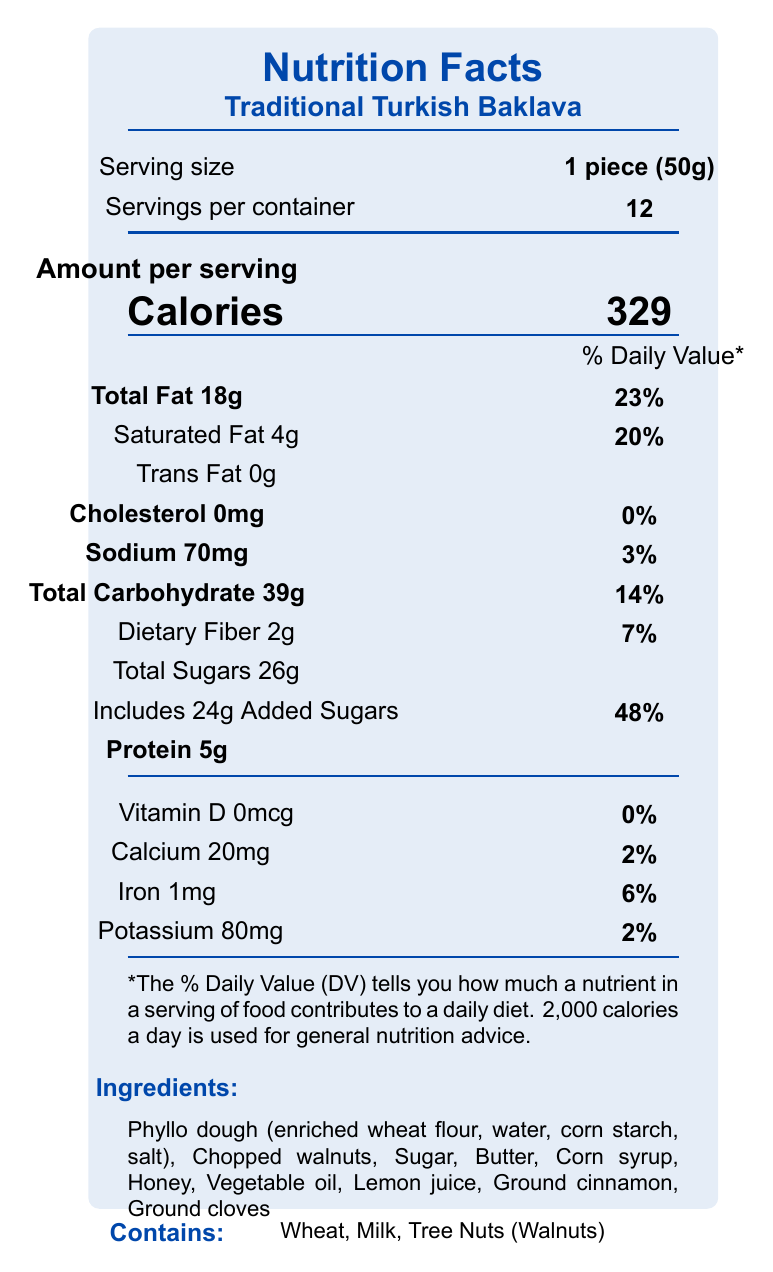What is the calorie content per serving? The document states that there are 329 calories per serving of the Traditional Turkish Baklava.
Answer: 329 calories What is the serving size of the Traditional Turkish Baklava? The serving size is listed as 1 piece, which is approximately 50 grams.
Answer: 1 piece (50g) How many servings are there per container? The document indicates that there are 12 servings per container.
Answer: 12 How much total sugar is in one serving? The document specifies that each serving contains 26 grams of total sugars.
Answer: 26g What are the daily values for saturated fat and sodium? Saturated fat has a daily value of 20% and sodium has a daily value of 3%.
Answer: Saturated Fat: 20%, Sodium: 3% What ingredients are listed as allergens? The document lists wheat, milk, and tree nuts (walnuts) as allergens.
Answer: Wheat, Milk, Tree Nuts (Walnuts) What is the amount of dietary fiber per serving? The document shows that there are 2 grams of dietary fiber per serving.
Answer: 2g Which nutrient contributes 48% of the daily value per serving? The document indicates that added sugars contribute 48% to the daily value.
Answer: Added Sugars How much protein is in one piece of baklava? According to the document, there are 5 grams of protein in each serving.
Answer: 5g How should the baklava be stored according to the storage instructions? The document suggests storing the baklava in an airtight container at room temperature for up to 5 days.
Answer: Store in an airtight container at room temperature for up to 5 days What is the daily value percentage for calcium? The document lists the daily value percentage for calcium as 2%.
Answer: 2% What are the main ingredients in the Traditional Turkish Baklava? A. Phyllo dough, walnuts, sugar B. Butter, corn syrup, honey C. Vegetable oil, lemon juice, cinnamon D. All of the above The main ingredients include phyllo dough, walnuts, sugar, butter, corn syrup, honey, vegetable oil, lemon juice, and cinnamon, which are all included in the options.
Answer: D. All of the above Which of the following nutrients is not present in the baklava? I. Vitamin D II. Cholesterol III. Trans Fat A. I only B. I and II only C. II and III only D. I, II, and III The document indicates that Vitamin D, cholesterol, and trans fat are all not present in the baklava.
Answer: D. I, II, and III Is there any cholesterol in the Traditional Turkish Baklava? The document states that the amount of cholesterol is 0mg, which means there is no cholesterol in the baklava.
Answer: No Summarize the key nutritional information and additional details provided about the Traditional Turkish Baklava. The summary covers the key nutritional information, including calorie content, macronutrient levels, daily value percentages for various nutrients, ingredients, allergen information, and storage instructions, along with a cultural note and manufacturer details.
Answer: The Traditional Turkish Baklava has a serving size of 1 piece (50g), with 12 servings per container. Each serving contains 329 calories, 18g total fat (23% DV), 4g saturated fat (20% DV), 0g trans fat, 0mg cholesterol, 70mg sodium (3% DV), 39g total carbohydrate (14% DV), 2g dietary fiber (7% DV), 26g total sugars (including 24g added sugars, 48% DV), and 5g protein. No vitamin D, and low calcium (2% DV), iron (6% DV), and potassium (2% DV). Allergens include wheat, milk, and tree nuts (walnuts). The baklava is handmade in small batches without preservatives, using an authentic recipe from Istanbul. Storage suggests an airtight container at room temperature for up to 5 days, and it is manufactured by Boğaziçi Baklava in Queens, NY. Baklava is traditionally served during Ramadan and special occasions in Turkey. What is the manufacturing process of the baklava? The document does not provide specific details about the manufacturing process of the baklava.
Answer: Not enough information 